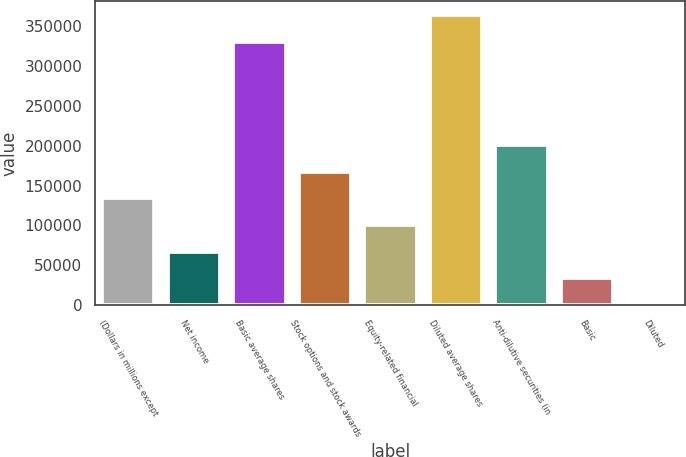<chart> <loc_0><loc_0><loc_500><loc_500><bar_chart><fcel>(Dollars in millions except<fcel>Net income<fcel>Basic average shares<fcel>Stock options and stock awards<fcel>Equity-related financial<fcel>Diluted average shares<fcel>Anti-dilutive securities (in<fcel>Basic<fcel>Diluted<nl><fcel>133856<fcel>66929.2<fcel>330361<fcel>167319<fcel>100393<fcel>363824<fcel>200783<fcel>33465.8<fcel>2.5<nl></chart> 